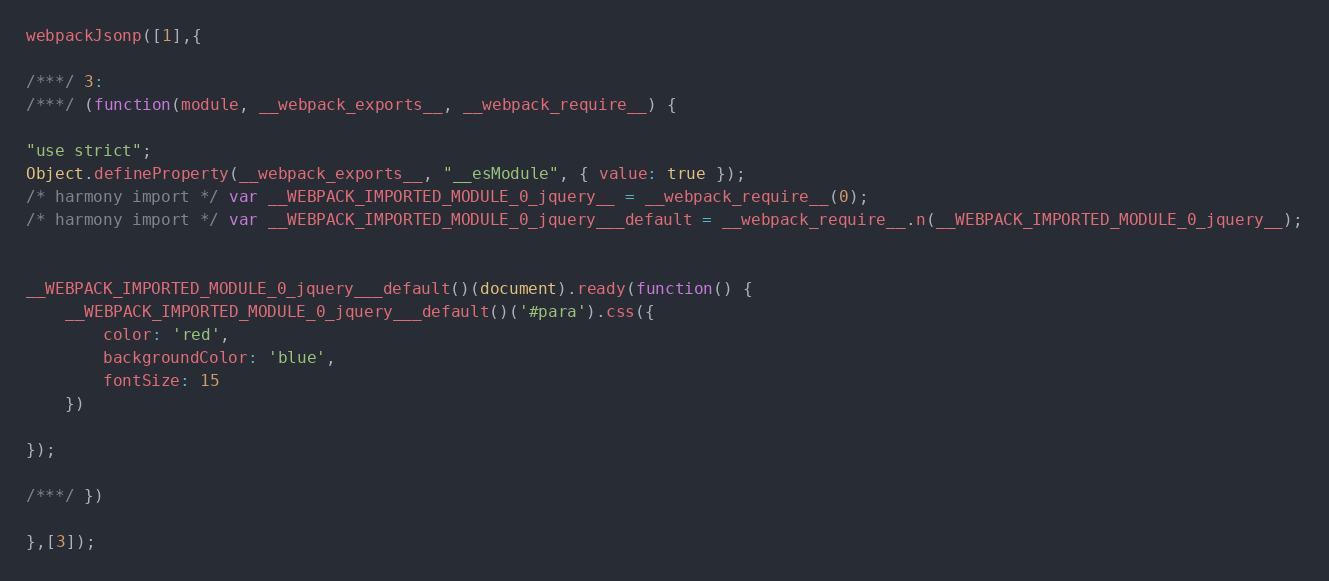Convert code to text. <code><loc_0><loc_0><loc_500><loc_500><_JavaScript_>webpackJsonp([1],{

/***/ 3:
/***/ (function(module, __webpack_exports__, __webpack_require__) {

"use strict";
Object.defineProperty(__webpack_exports__, "__esModule", { value: true });
/* harmony import */ var __WEBPACK_IMPORTED_MODULE_0_jquery__ = __webpack_require__(0);
/* harmony import */ var __WEBPACK_IMPORTED_MODULE_0_jquery___default = __webpack_require__.n(__WEBPACK_IMPORTED_MODULE_0_jquery__);


__WEBPACK_IMPORTED_MODULE_0_jquery___default()(document).ready(function() {
    __WEBPACK_IMPORTED_MODULE_0_jquery___default()('#para').css({
        color: 'red',
        backgroundColor: 'blue',
        fontSize: 15
    })

});

/***/ })

},[3]);</code> 